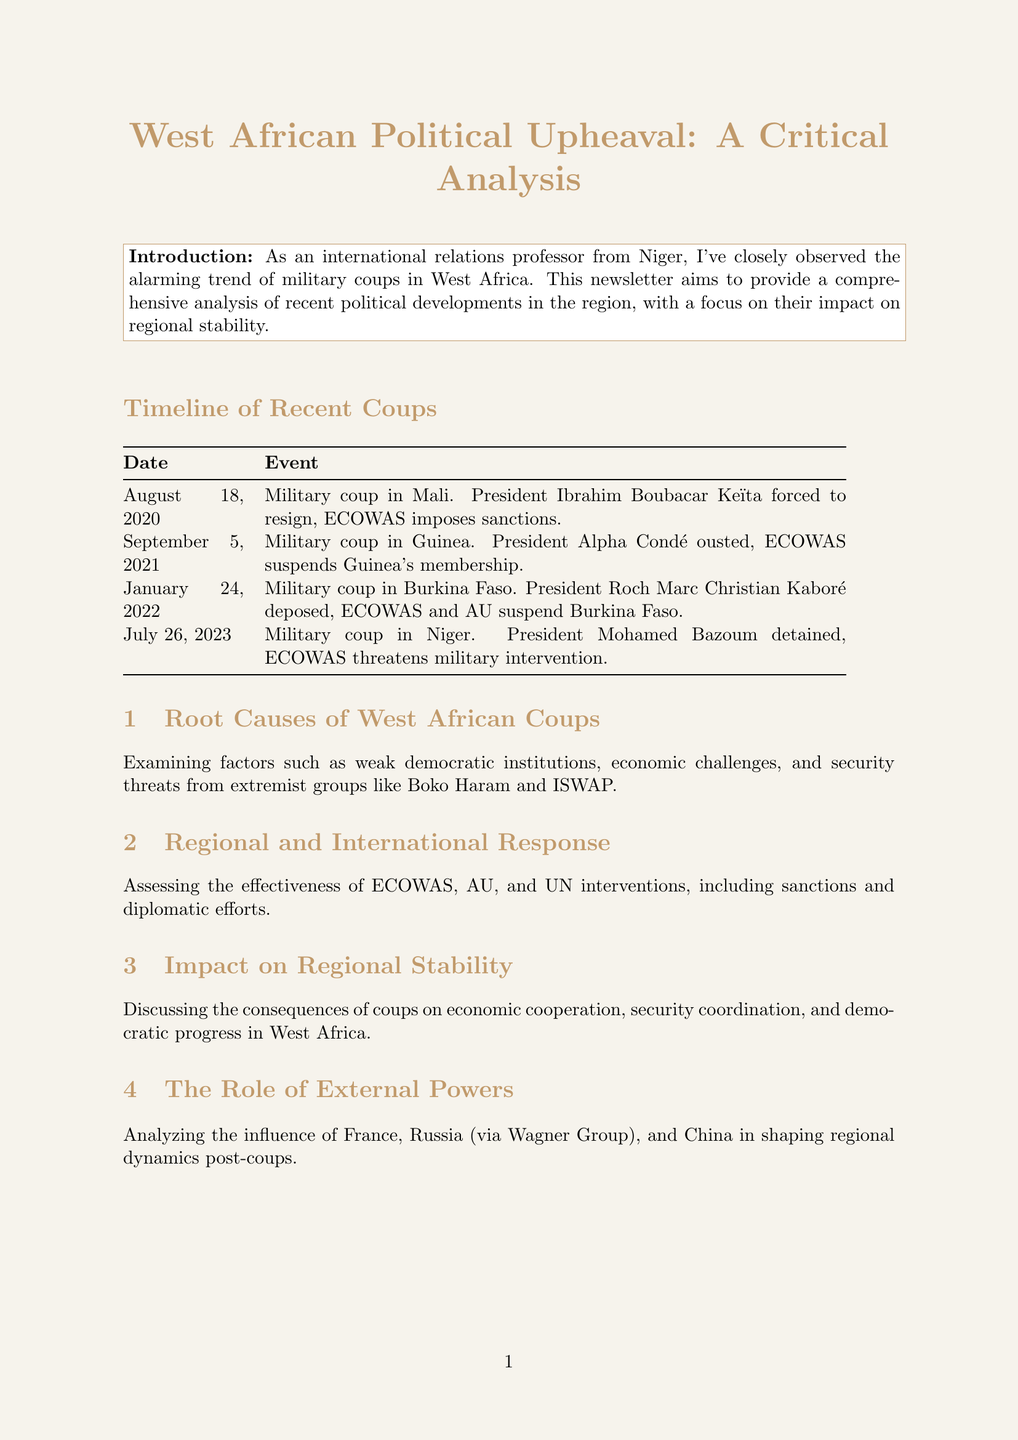what event occurred on August 18, 2020? The document states that this date marks a military coup in Mali, where President Ibrahim Boubacar Keïta was forced to resign.
Answer: Military coup in Mali which organization imposed sanctions after the coup in Mali? According to the timeline, ECOWAS imposed sanctions following the military coup in Mali.
Answer: ECOWAS what is one of the root causes of West African coups mentioned in the analysis? The analysis section discusses several factors, including weak democratic institutions as a root cause of the coups.
Answer: Weak democratic institutions how many coups are listed in the timeline? By counting the events in the timeline, there are four coups mentioned.
Answer: Four what does the expert opinion primarily condemn? The expert opinion expresses strong condemnation of the recent wave of military coups in the region.
Answer: Recent wave of military coups which country experienced a coup on January 24, 2022? The document specifies that Burkina Faso experienced a military coup on this date.
Answer: Burkina Faso what is one recommendation given in the newsletter? The document lists multiple recommendations, one being to strengthen democratic institutions and promote good governance.
Answer: Strengthen democratic institutions and promote good governance who was the president detained during the coup in Niger? The newsletter identifies President Mohamed Bazoum as the one detained during the coup in Niger.
Answer: Mohamed Bazoum 